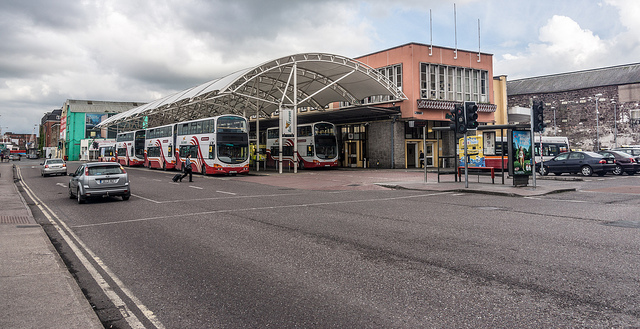What mass transit units sit parked here?
A. trains
B. cabs
C. cars
D. busses
Answer with the option's letter from the given choices directly. The correct answer is D, which corresponds to buses. You can see several buses parked outside the bus station, distinguished by their large size and styling specific for carrying multiple passengers. This facility, as depicted, serves as a fundamental hub in urban transit, efficiently supporting public transport by facilitating these buses. 